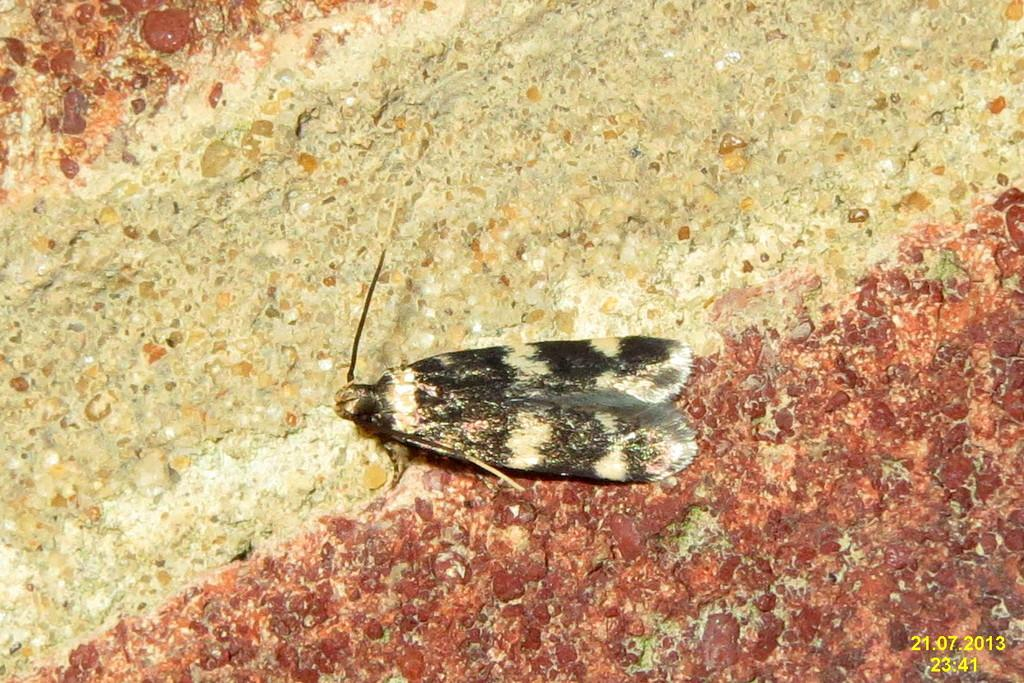What type of creature can be seen in the image? There is an insect in the image. Where is the insect located? The insect is sitting on a floor. Can you describe the pattern on the floor? The floor has a red and white pattern. What time of day is it in the image? The time of day is not mentioned or visible in the image, so it cannot be determined. 